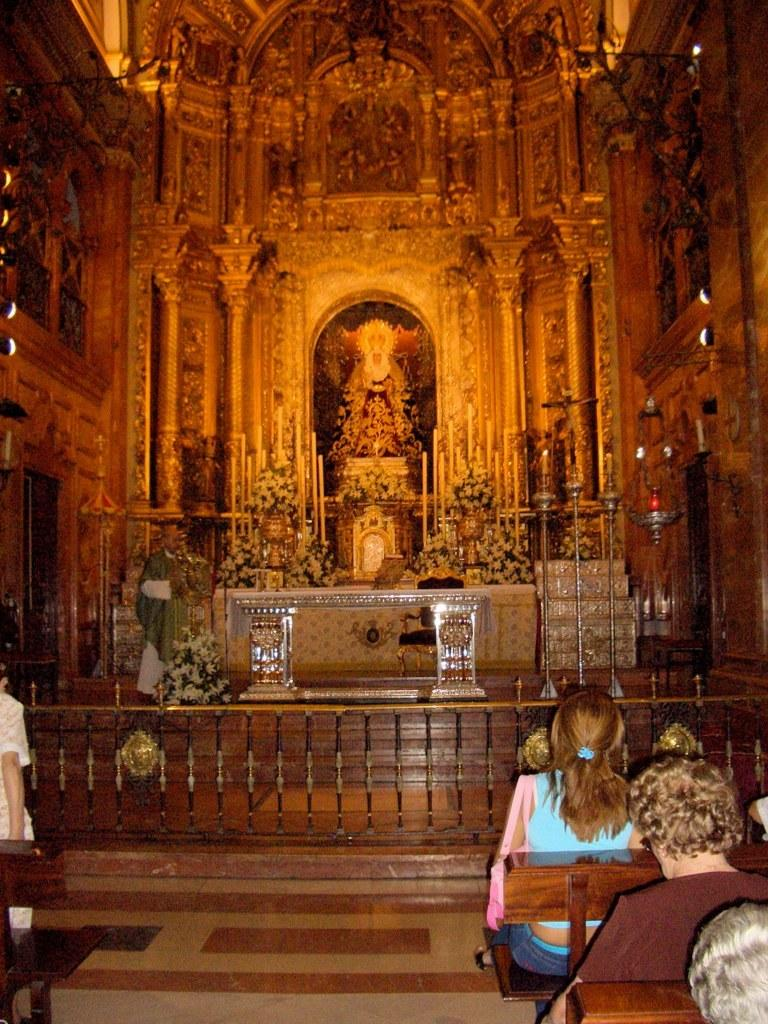What are the people in the image doing? There are persons sitting on benches in the image. Can you describe the person in the background? There is a person standing in the background of the image. What can be seen in the background of the image? The interior of a building and a sculpture are visible in the background of the image. How many cattle are present in the image? There are no cattle present in the image. What type of oven is visible in the image? There is no oven present in the image. 